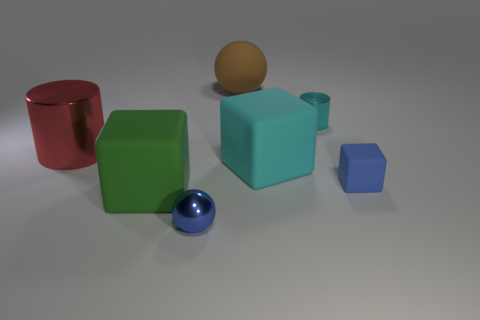Is there anything else that has the same size as the cyan matte block?
Keep it short and to the point. Yes. There is a ball that is behind the cylinder that is on the left side of the rubber sphere; what is it made of?
Your answer should be compact. Rubber. Is the shape of the large cyan matte object the same as the large green matte object?
Make the answer very short. Yes. How many big things are in front of the red metallic object and on the right side of the large green rubber cube?
Keep it short and to the point. 1. Are there an equal number of small blocks left of the cyan cylinder and big shiny cylinders in front of the large red shiny thing?
Offer a terse response. Yes. Is the size of the ball that is on the left side of the big ball the same as the rubber thing in front of the blue matte cube?
Your answer should be very brief. No. There is a tiny object that is left of the small blue matte object and behind the green rubber object; what material is it made of?
Provide a succinct answer. Metal. Are there fewer green metallic blocks than blue shiny things?
Offer a terse response. Yes. There is a shiny cylinder that is on the left side of the shiny cylinder right of the big cylinder; how big is it?
Offer a very short reply. Large. What shape is the brown matte object behind the cyan object that is to the left of the small shiny thing behind the small blue cube?
Keep it short and to the point. Sphere. 